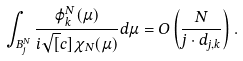Convert formula to latex. <formula><loc_0><loc_0><loc_500><loc_500>\int _ { B _ { j } ^ { N } } \frac { \varphi ^ { N } _ { k } ( \mu ) } { i \sqrt { [ } c ] { \chi _ { N } ( \mu ) } } d \mu = O \left ( \frac { N } { j \cdot d _ { j , k } } \right ) .</formula> 